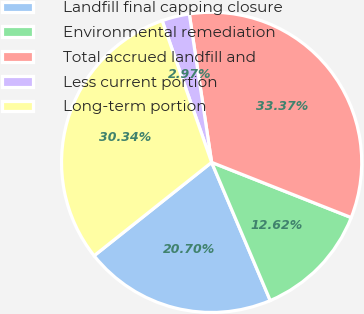Convert chart. <chart><loc_0><loc_0><loc_500><loc_500><pie_chart><fcel>Landfill final capping closure<fcel>Environmental remediation<fcel>Total accrued landfill and<fcel>Less current portion<fcel>Long-term portion<nl><fcel>20.7%<fcel>12.62%<fcel>33.37%<fcel>2.97%<fcel>30.34%<nl></chart> 